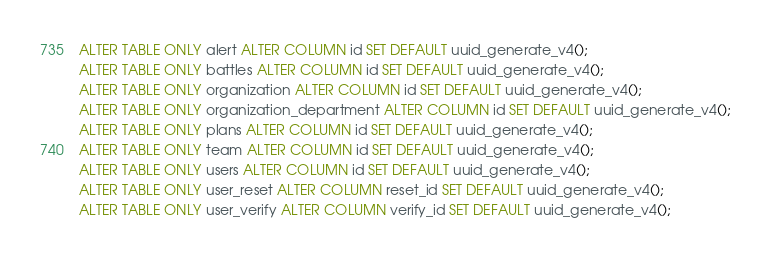Convert code to text. <code><loc_0><loc_0><loc_500><loc_500><_SQL_>ALTER TABLE ONLY alert ALTER COLUMN id SET DEFAULT uuid_generate_v4();
ALTER TABLE ONLY battles ALTER COLUMN id SET DEFAULT uuid_generate_v4();
ALTER TABLE ONLY organization ALTER COLUMN id SET DEFAULT uuid_generate_v4();
ALTER TABLE ONLY organization_department ALTER COLUMN id SET DEFAULT uuid_generate_v4();
ALTER TABLE ONLY plans ALTER COLUMN id SET DEFAULT uuid_generate_v4();
ALTER TABLE ONLY team ALTER COLUMN id SET DEFAULT uuid_generate_v4();
ALTER TABLE ONLY users ALTER COLUMN id SET DEFAULT uuid_generate_v4();
ALTER TABLE ONLY user_reset ALTER COLUMN reset_id SET DEFAULT uuid_generate_v4();
ALTER TABLE ONLY user_verify ALTER COLUMN verify_id SET DEFAULT uuid_generate_v4();</code> 